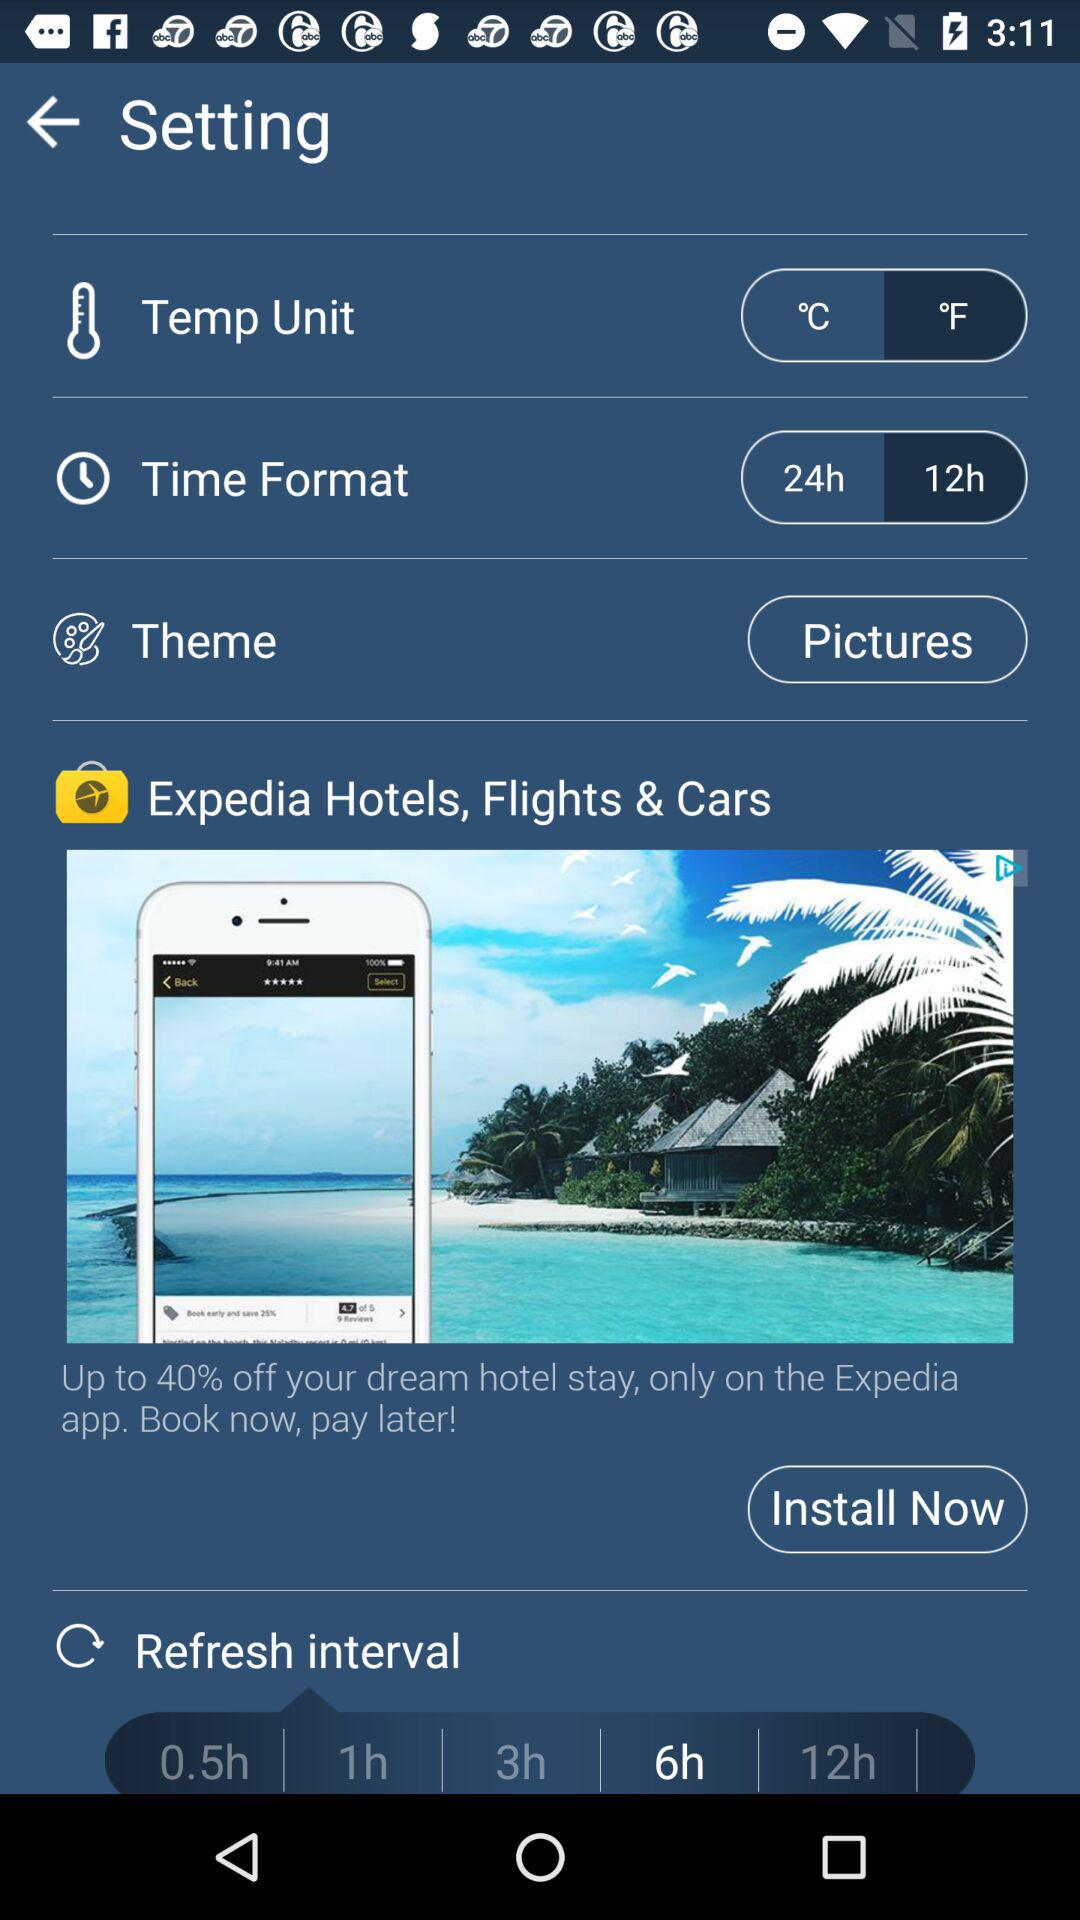What is the time format? The time format is 12 hours. 